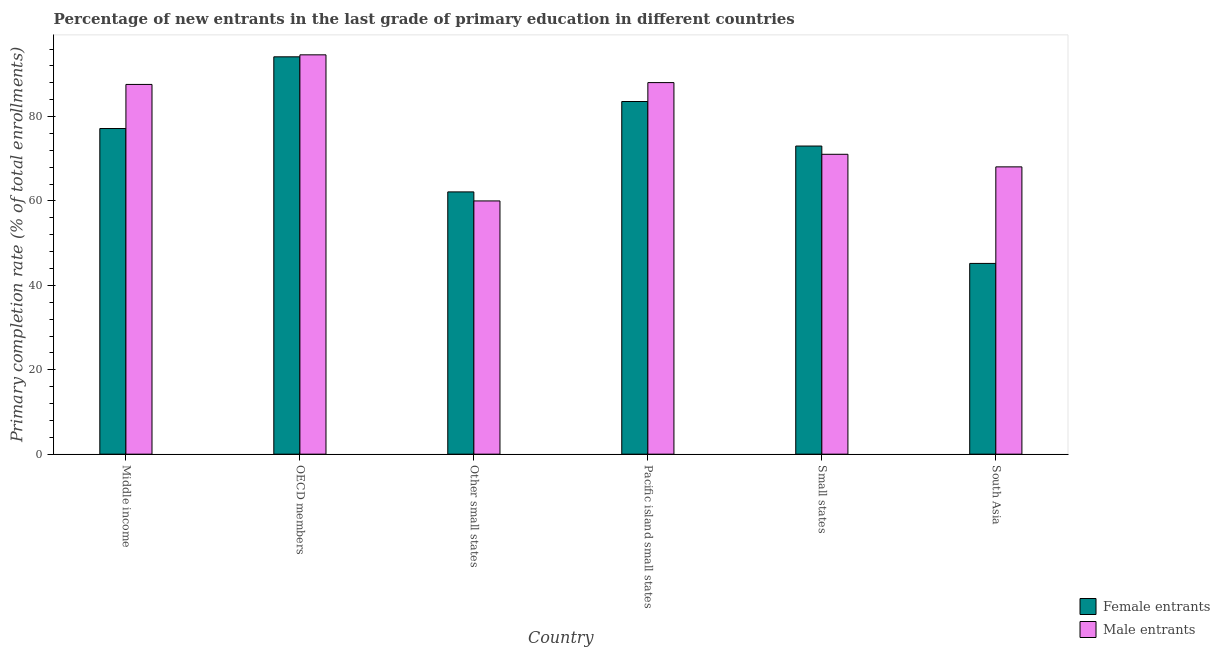How many groups of bars are there?
Give a very brief answer. 6. Are the number of bars per tick equal to the number of legend labels?
Your response must be concise. Yes. How many bars are there on the 4th tick from the left?
Offer a very short reply. 2. What is the label of the 3rd group of bars from the left?
Keep it short and to the point. Other small states. In how many cases, is the number of bars for a given country not equal to the number of legend labels?
Provide a succinct answer. 0. What is the primary completion rate of female entrants in Other small states?
Offer a terse response. 62.16. Across all countries, what is the maximum primary completion rate of male entrants?
Your response must be concise. 94.64. Across all countries, what is the minimum primary completion rate of male entrants?
Provide a succinct answer. 60.02. In which country was the primary completion rate of female entrants maximum?
Provide a short and direct response. OECD members. In which country was the primary completion rate of male entrants minimum?
Provide a short and direct response. Other small states. What is the total primary completion rate of male entrants in the graph?
Provide a succinct answer. 469.5. What is the difference between the primary completion rate of male entrants in Middle income and that in South Asia?
Give a very brief answer. 19.54. What is the difference between the primary completion rate of male entrants in South Asia and the primary completion rate of female entrants in Other small states?
Keep it short and to the point. 5.93. What is the average primary completion rate of female entrants per country?
Your answer should be very brief. 72.55. What is the difference between the primary completion rate of male entrants and primary completion rate of female entrants in South Asia?
Your answer should be very brief. 22.88. What is the ratio of the primary completion rate of male entrants in Middle income to that in Other small states?
Offer a terse response. 1.46. Is the primary completion rate of male entrants in Middle income less than that in OECD members?
Provide a short and direct response. Yes. What is the difference between the highest and the second highest primary completion rate of female entrants?
Provide a succinct answer. 10.59. What is the difference between the highest and the lowest primary completion rate of male entrants?
Your answer should be very brief. 34.62. Is the sum of the primary completion rate of male entrants in Middle income and Pacific island small states greater than the maximum primary completion rate of female entrants across all countries?
Ensure brevity in your answer.  Yes. What does the 1st bar from the left in Small states represents?
Your answer should be very brief. Female entrants. What does the 2nd bar from the right in Small states represents?
Your answer should be compact. Female entrants. How many countries are there in the graph?
Your answer should be compact. 6. Does the graph contain grids?
Give a very brief answer. No. What is the title of the graph?
Provide a succinct answer. Percentage of new entrants in the last grade of primary education in different countries. Does "Travel services" appear as one of the legend labels in the graph?
Provide a short and direct response. No. What is the label or title of the Y-axis?
Provide a succinct answer. Primary completion rate (% of total enrollments). What is the Primary completion rate (% of total enrollments) in Female entrants in Middle income?
Give a very brief answer. 77.17. What is the Primary completion rate (% of total enrollments) of Male entrants in Middle income?
Make the answer very short. 87.63. What is the Primary completion rate (% of total enrollments) of Female entrants in OECD members?
Your answer should be compact. 94.17. What is the Primary completion rate (% of total enrollments) in Male entrants in OECD members?
Provide a short and direct response. 94.64. What is the Primary completion rate (% of total enrollments) of Female entrants in Other small states?
Provide a short and direct response. 62.16. What is the Primary completion rate (% of total enrollments) in Male entrants in Other small states?
Your answer should be compact. 60.02. What is the Primary completion rate (% of total enrollments) in Female entrants in Pacific island small states?
Your answer should be very brief. 83.58. What is the Primary completion rate (% of total enrollments) in Male entrants in Pacific island small states?
Your answer should be very brief. 88.06. What is the Primary completion rate (% of total enrollments) of Female entrants in Small states?
Your answer should be compact. 73.03. What is the Primary completion rate (% of total enrollments) in Male entrants in Small states?
Offer a very short reply. 71.07. What is the Primary completion rate (% of total enrollments) in Female entrants in South Asia?
Make the answer very short. 45.21. What is the Primary completion rate (% of total enrollments) of Male entrants in South Asia?
Your answer should be compact. 68.09. Across all countries, what is the maximum Primary completion rate (% of total enrollments) of Female entrants?
Offer a very short reply. 94.17. Across all countries, what is the maximum Primary completion rate (% of total enrollments) in Male entrants?
Offer a very short reply. 94.64. Across all countries, what is the minimum Primary completion rate (% of total enrollments) of Female entrants?
Provide a short and direct response. 45.21. Across all countries, what is the minimum Primary completion rate (% of total enrollments) in Male entrants?
Give a very brief answer. 60.02. What is the total Primary completion rate (% of total enrollments) in Female entrants in the graph?
Offer a terse response. 435.32. What is the total Primary completion rate (% of total enrollments) in Male entrants in the graph?
Ensure brevity in your answer.  469.5. What is the difference between the Primary completion rate (% of total enrollments) in Female entrants in Middle income and that in OECD members?
Offer a very short reply. -17. What is the difference between the Primary completion rate (% of total enrollments) of Male entrants in Middle income and that in OECD members?
Provide a short and direct response. -7.01. What is the difference between the Primary completion rate (% of total enrollments) in Female entrants in Middle income and that in Other small states?
Make the answer very short. 15.02. What is the difference between the Primary completion rate (% of total enrollments) of Male entrants in Middle income and that in Other small states?
Your answer should be compact. 27.61. What is the difference between the Primary completion rate (% of total enrollments) in Female entrants in Middle income and that in Pacific island small states?
Your answer should be very brief. -6.4. What is the difference between the Primary completion rate (% of total enrollments) of Male entrants in Middle income and that in Pacific island small states?
Offer a very short reply. -0.43. What is the difference between the Primary completion rate (% of total enrollments) of Female entrants in Middle income and that in Small states?
Your answer should be very brief. 4.15. What is the difference between the Primary completion rate (% of total enrollments) in Male entrants in Middle income and that in Small states?
Your answer should be compact. 16.56. What is the difference between the Primary completion rate (% of total enrollments) of Female entrants in Middle income and that in South Asia?
Keep it short and to the point. 31.97. What is the difference between the Primary completion rate (% of total enrollments) of Male entrants in Middle income and that in South Asia?
Offer a very short reply. 19.54. What is the difference between the Primary completion rate (% of total enrollments) of Female entrants in OECD members and that in Other small states?
Offer a very short reply. 32.01. What is the difference between the Primary completion rate (% of total enrollments) of Male entrants in OECD members and that in Other small states?
Give a very brief answer. 34.62. What is the difference between the Primary completion rate (% of total enrollments) in Female entrants in OECD members and that in Pacific island small states?
Your answer should be compact. 10.59. What is the difference between the Primary completion rate (% of total enrollments) in Male entrants in OECD members and that in Pacific island small states?
Your answer should be compact. 6.58. What is the difference between the Primary completion rate (% of total enrollments) of Female entrants in OECD members and that in Small states?
Keep it short and to the point. 21.14. What is the difference between the Primary completion rate (% of total enrollments) of Male entrants in OECD members and that in Small states?
Give a very brief answer. 23.57. What is the difference between the Primary completion rate (% of total enrollments) of Female entrants in OECD members and that in South Asia?
Your answer should be very brief. 48.96. What is the difference between the Primary completion rate (% of total enrollments) in Male entrants in OECD members and that in South Asia?
Your answer should be very brief. 26.55. What is the difference between the Primary completion rate (% of total enrollments) of Female entrants in Other small states and that in Pacific island small states?
Your response must be concise. -21.42. What is the difference between the Primary completion rate (% of total enrollments) of Male entrants in Other small states and that in Pacific island small states?
Keep it short and to the point. -28.04. What is the difference between the Primary completion rate (% of total enrollments) of Female entrants in Other small states and that in Small states?
Offer a terse response. -10.87. What is the difference between the Primary completion rate (% of total enrollments) of Male entrants in Other small states and that in Small states?
Ensure brevity in your answer.  -11.05. What is the difference between the Primary completion rate (% of total enrollments) of Female entrants in Other small states and that in South Asia?
Make the answer very short. 16.95. What is the difference between the Primary completion rate (% of total enrollments) of Male entrants in Other small states and that in South Asia?
Provide a short and direct response. -8.07. What is the difference between the Primary completion rate (% of total enrollments) of Female entrants in Pacific island small states and that in Small states?
Keep it short and to the point. 10.55. What is the difference between the Primary completion rate (% of total enrollments) of Male entrants in Pacific island small states and that in Small states?
Offer a terse response. 16.99. What is the difference between the Primary completion rate (% of total enrollments) in Female entrants in Pacific island small states and that in South Asia?
Your answer should be very brief. 38.37. What is the difference between the Primary completion rate (% of total enrollments) in Male entrants in Pacific island small states and that in South Asia?
Ensure brevity in your answer.  19.97. What is the difference between the Primary completion rate (% of total enrollments) of Female entrants in Small states and that in South Asia?
Offer a very short reply. 27.82. What is the difference between the Primary completion rate (% of total enrollments) of Male entrants in Small states and that in South Asia?
Your answer should be compact. 2.98. What is the difference between the Primary completion rate (% of total enrollments) of Female entrants in Middle income and the Primary completion rate (% of total enrollments) of Male entrants in OECD members?
Your answer should be compact. -17.46. What is the difference between the Primary completion rate (% of total enrollments) in Female entrants in Middle income and the Primary completion rate (% of total enrollments) in Male entrants in Other small states?
Offer a very short reply. 17.16. What is the difference between the Primary completion rate (% of total enrollments) in Female entrants in Middle income and the Primary completion rate (% of total enrollments) in Male entrants in Pacific island small states?
Give a very brief answer. -10.88. What is the difference between the Primary completion rate (% of total enrollments) of Female entrants in Middle income and the Primary completion rate (% of total enrollments) of Male entrants in Small states?
Ensure brevity in your answer.  6.1. What is the difference between the Primary completion rate (% of total enrollments) of Female entrants in Middle income and the Primary completion rate (% of total enrollments) of Male entrants in South Asia?
Offer a terse response. 9.09. What is the difference between the Primary completion rate (% of total enrollments) of Female entrants in OECD members and the Primary completion rate (% of total enrollments) of Male entrants in Other small states?
Provide a succinct answer. 34.16. What is the difference between the Primary completion rate (% of total enrollments) in Female entrants in OECD members and the Primary completion rate (% of total enrollments) in Male entrants in Pacific island small states?
Keep it short and to the point. 6.11. What is the difference between the Primary completion rate (% of total enrollments) in Female entrants in OECD members and the Primary completion rate (% of total enrollments) in Male entrants in Small states?
Keep it short and to the point. 23.1. What is the difference between the Primary completion rate (% of total enrollments) of Female entrants in OECD members and the Primary completion rate (% of total enrollments) of Male entrants in South Asia?
Provide a short and direct response. 26.08. What is the difference between the Primary completion rate (% of total enrollments) in Female entrants in Other small states and the Primary completion rate (% of total enrollments) in Male entrants in Pacific island small states?
Your response must be concise. -25.9. What is the difference between the Primary completion rate (% of total enrollments) of Female entrants in Other small states and the Primary completion rate (% of total enrollments) of Male entrants in Small states?
Your answer should be compact. -8.91. What is the difference between the Primary completion rate (% of total enrollments) in Female entrants in Other small states and the Primary completion rate (% of total enrollments) in Male entrants in South Asia?
Keep it short and to the point. -5.93. What is the difference between the Primary completion rate (% of total enrollments) of Female entrants in Pacific island small states and the Primary completion rate (% of total enrollments) of Male entrants in Small states?
Give a very brief answer. 12.51. What is the difference between the Primary completion rate (% of total enrollments) in Female entrants in Pacific island small states and the Primary completion rate (% of total enrollments) in Male entrants in South Asia?
Keep it short and to the point. 15.49. What is the difference between the Primary completion rate (% of total enrollments) in Female entrants in Small states and the Primary completion rate (% of total enrollments) in Male entrants in South Asia?
Give a very brief answer. 4.94. What is the average Primary completion rate (% of total enrollments) of Female entrants per country?
Offer a very short reply. 72.55. What is the average Primary completion rate (% of total enrollments) of Male entrants per country?
Ensure brevity in your answer.  78.25. What is the difference between the Primary completion rate (% of total enrollments) of Female entrants and Primary completion rate (% of total enrollments) of Male entrants in Middle income?
Offer a terse response. -10.45. What is the difference between the Primary completion rate (% of total enrollments) of Female entrants and Primary completion rate (% of total enrollments) of Male entrants in OECD members?
Your answer should be very brief. -0.47. What is the difference between the Primary completion rate (% of total enrollments) of Female entrants and Primary completion rate (% of total enrollments) of Male entrants in Other small states?
Ensure brevity in your answer.  2.14. What is the difference between the Primary completion rate (% of total enrollments) of Female entrants and Primary completion rate (% of total enrollments) of Male entrants in Pacific island small states?
Offer a very short reply. -4.48. What is the difference between the Primary completion rate (% of total enrollments) in Female entrants and Primary completion rate (% of total enrollments) in Male entrants in Small states?
Your answer should be compact. 1.96. What is the difference between the Primary completion rate (% of total enrollments) of Female entrants and Primary completion rate (% of total enrollments) of Male entrants in South Asia?
Your response must be concise. -22.88. What is the ratio of the Primary completion rate (% of total enrollments) in Female entrants in Middle income to that in OECD members?
Your answer should be compact. 0.82. What is the ratio of the Primary completion rate (% of total enrollments) in Male entrants in Middle income to that in OECD members?
Provide a short and direct response. 0.93. What is the ratio of the Primary completion rate (% of total enrollments) of Female entrants in Middle income to that in Other small states?
Provide a succinct answer. 1.24. What is the ratio of the Primary completion rate (% of total enrollments) in Male entrants in Middle income to that in Other small states?
Provide a short and direct response. 1.46. What is the ratio of the Primary completion rate (% of total enrollments) of Female entrants in Middle income to that in Pacific island small states?
Provide a short and direct response. 0.92. What is the ratio of the Primary completion rate (% of total enrollments) of Female entrants in Middle income to that in Small states?
Your answer should be very brief. 1.06. What is the ratio of the Primary completion rate (% of total enrollments) of Male entrants in Middle income to that in Small states?
Provide a succinct answer. 1.23. What is the ratio of the Primary completion rate (% of total enrollments) in Female entrants in Middle income to that in South Asia?
Ensure brevity in your answer.  1.71. What is the ratio of the Primary completion rate (% of total enrollments) of Male entrants in Middle income to that in South Asia?
Give a very brief answer. 1.29. What is the ratio of the Primary completion rate (% of total enrollments) in Female entrants in OECD members to that in Other small states?
Your response must be concise. 1.51. What is the ratio of the Primary completion rate (% of total enrollments) of Male entrants in OECD members to that in Other small states?
Provide a succinct answer. 1.58. What is the ratio of the Primary completion rate (% of total enrollments) in Female entrants in OECD members to that in Pacific island small states?
Provide a succinct answer. 1.13. What is the ratio of the Primary completion rate (% of total enrollments) in Male entrants in OECD members to that in Pacific island small states?
Give a very brief answer. 1.07. What is the ratio of the Primary completion rate (% of total enrollments) in Female entrants in OECD members to that in Small states?
Make the answer very short. 1.29. What is the ratio of the Primary completion rate (% of total enrollments) in Male entrants in OECD members to that in Small states?
Offer a terse response. 1.33. What is the ratio of the Primary completion rate (% of total enrollments) in Female entrants in OECD members to that in South Asia?
Keep it short and to the point. 2.08. What is the ratio of the Primary completion rate (% of total enrollments) in Male entrants in OECD members to that in South Asia?
Offer a very short reply. 1.39. What is the ratio of the Primary completion rate (% of total enrollments) of Female entrants in Other small states to that in Pacific island small states?
Your answer should be very brief. 0.74. What is the ratio of the Primary completion rate (% of total enrollments) of Male entrants in Other small states to that in Pacific island small states?
Give a very brief answer. 0.68. What is the ratio of the Primary completion rate (% of total enrollments) in Female entrants in Other small states to that in Small states?
Offer a very short reply. 0.85. What is the ratio of the Primary completion rate (% of total enrollments) in Male entrants in Other small states to that in Small states?
Your answer should be compact. 0.84. What is the ratio of the Primary completion rate (% of total enrollments) in Female entrants in Other small states to that in South Asia?
Your response must be concise. 1.37. What is the ratio of the Primary completion rate (% of total enrollments) of Male entrants in Other small states to that in South Asia?
Offer a very short reply. 0.88. What is the ratio of the Primary completion rate (% of total enrollments) in Female entrants in Pacific island small states to that in Small states?
Your answer should be very brief. 1.14. What is the ratio of the Primary completion rate (% of total enrollments) in Male entrants in Pacific island small states to that in Small states?
Your response must be concise. 1.24. What is the ratio of the Primary completion rate (% of total enrollments) of Female entrants in Pacific island small states to that in South Asia?
Make the answer very short. 1.85. What is the ratio of the Primary completion rate (% of total enrollments) of Male entrants in Pacific island small states to that in South Asia?
Your answer should be compact. 1.29. What is the ratio of the Primary completion rate (% of total enrollments) of Female entrants in Small states to that in South Asia?
Offer a terse response. 1.62. What is the ratio of the Primary completion rate (% of total enrollments) in Male entrants in Small states to that in South Asia?
Ensure brevity in your answer.  1.04. What is the difference between the highest and the second highest Primary completion rate (% of total enrollments) in Female entrants?
Make the answer very short. 10.59. What is the difference between the highest and the second highest Primary completion rate (% of total enrollments) in Male entrants?
Provide a short and direct response. 6.58. What is the difference between the highest and the lowest Primary completion rate (% of total enrollments) in Female entrants?
Ensure brevity in your answer.  48.96. What is the difference between the highest and the lowest Primary completion rate (% of total enrollments) of Male entrants?
Your response must be concise. 34.62. 